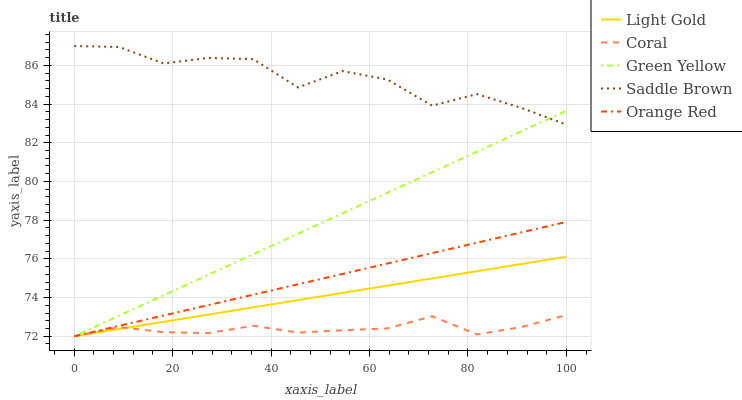Does Coral have the minimum area under the curve?
Answer yes or no. Yes. Does Saddle Brown have the maximum area under the curve?
Answer yes or no. Yes. Does Green Yellow have the minimum area under the curve?
Answer yes or no. No. Does Green Yellow have the maximum area under the curve?
Answer yes or no. No. Is Light Gold the smoothest?
Answer yes or no. Yes. Is Saddle Brown the roughest?
Answer yes or no. Yes. Is Green Yellow the smoothest?
Answer yes or no. No. Is Green Yellow the roughest?
Answer yes or no. No. Does Coral have the lowest value?
Answer yes or no. Yes. Does Saddle Brown have the lowest value?
Answer yes or no. No. Does Saddle Brown have the highest value?
Answer yes or no. Yes. Does Green Yellow have the highest value?
Answer yes or no. No. Is Orange Red less than Saddle Brown?
Answer yes or no. Yes. Is Saddle Brown greater than Coral?
Answer yes or no. Yes. Does Coral intersect Light Gold?
Answer yes or no. Yes. Is Coral less than Light Gold?
Answer yes or no. No. Is Coral greater than Light Gold?
Answer yes or no. No. Does Orange Red intersect Saddle Brown?
Answer yes or no. No. 